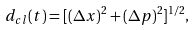Convert formula to latex. <formula><loc_0><loc_0><loc_500><loc_500>d _ { c l } ( t ) = [ ( \Delta x ) ^ { 2 } + ( \Delta p ) ^ { 2 } ] ^ { 1 / 2 } ,</formula> 